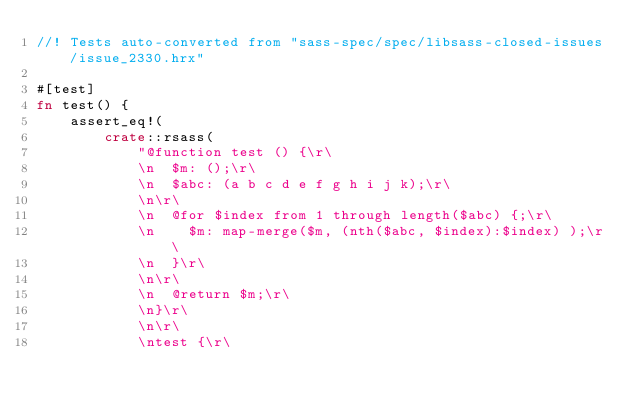Convert code to text. <code><loc_0><loc_0><loc_500><loc_500><_Rust_>//! Tests auto-converted from "sass-spec/spec/libsass-closed-issues/issue_2330.hrx"

#[test]
fn test() {
    assert_eq!(
        crate::rsass(
            "@function test () {\r\
            \n  $m: ();\r\
            \n  $abc: (a b c d e f g h i j k);\r\
            \n\r\
            \n  @for $index from 1 through length($abc) {;\r\
            \n    $m: map-merge($m, (nth($abc, $index):$index) );\r\
            \n  }\r\
            \n\r\
            \n  @return $m;\r\
            \n}\r\
            \n\r\
            \ntest {\r\</code> 